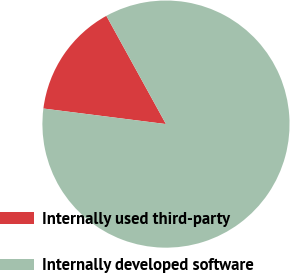<chart> <loc_0><loc_0><loc_500><loc_500><pie_chart><fcel>Internally used third-party<fcel>Internally developed software<nl><fcel>14.98%<fcel>85.02%<nl></chart> 